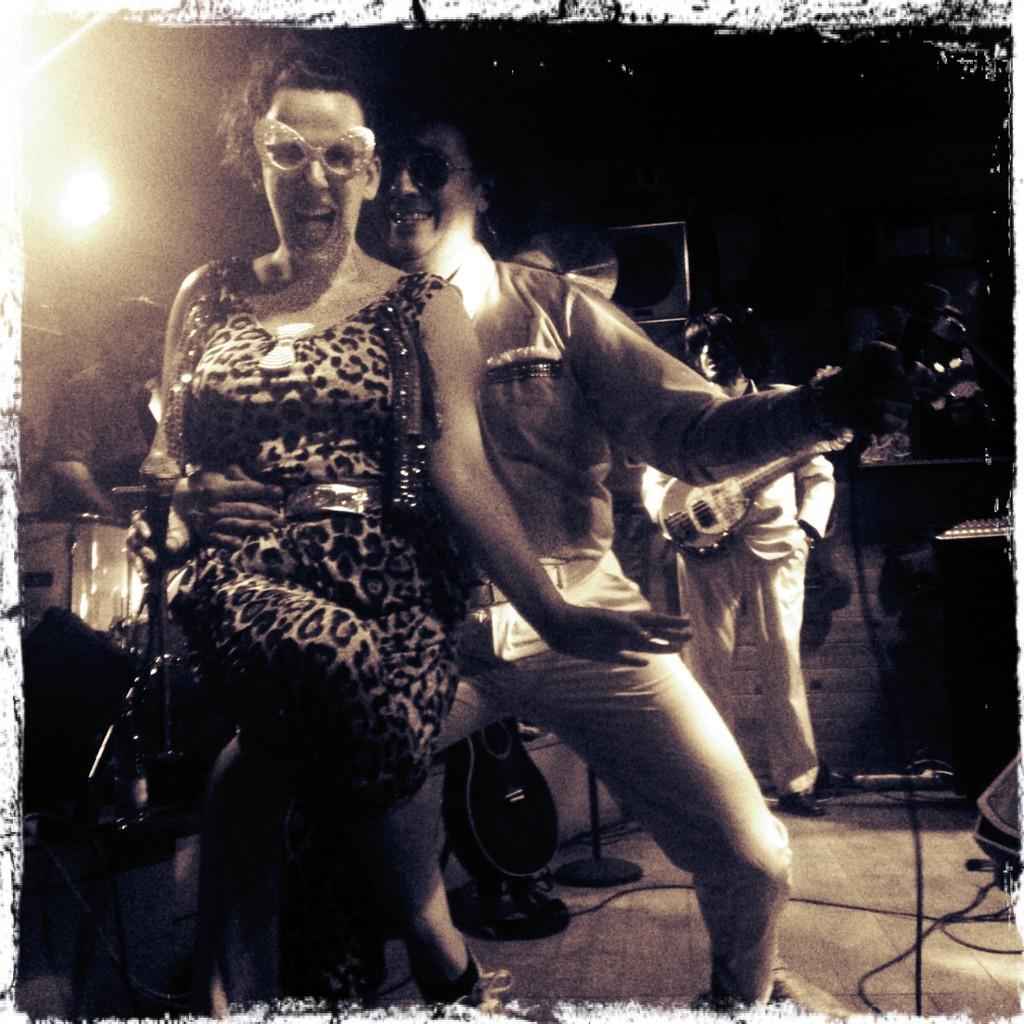In one or two sentences, can you explain what this image depicts? In this image in the front there are persons standing and smiling. In the background there are persons, on the left side there is a man standing and there is a musical instrument in front of the man. In the background there is a man standing and holding a musical instrument. On the left side there is a light. 